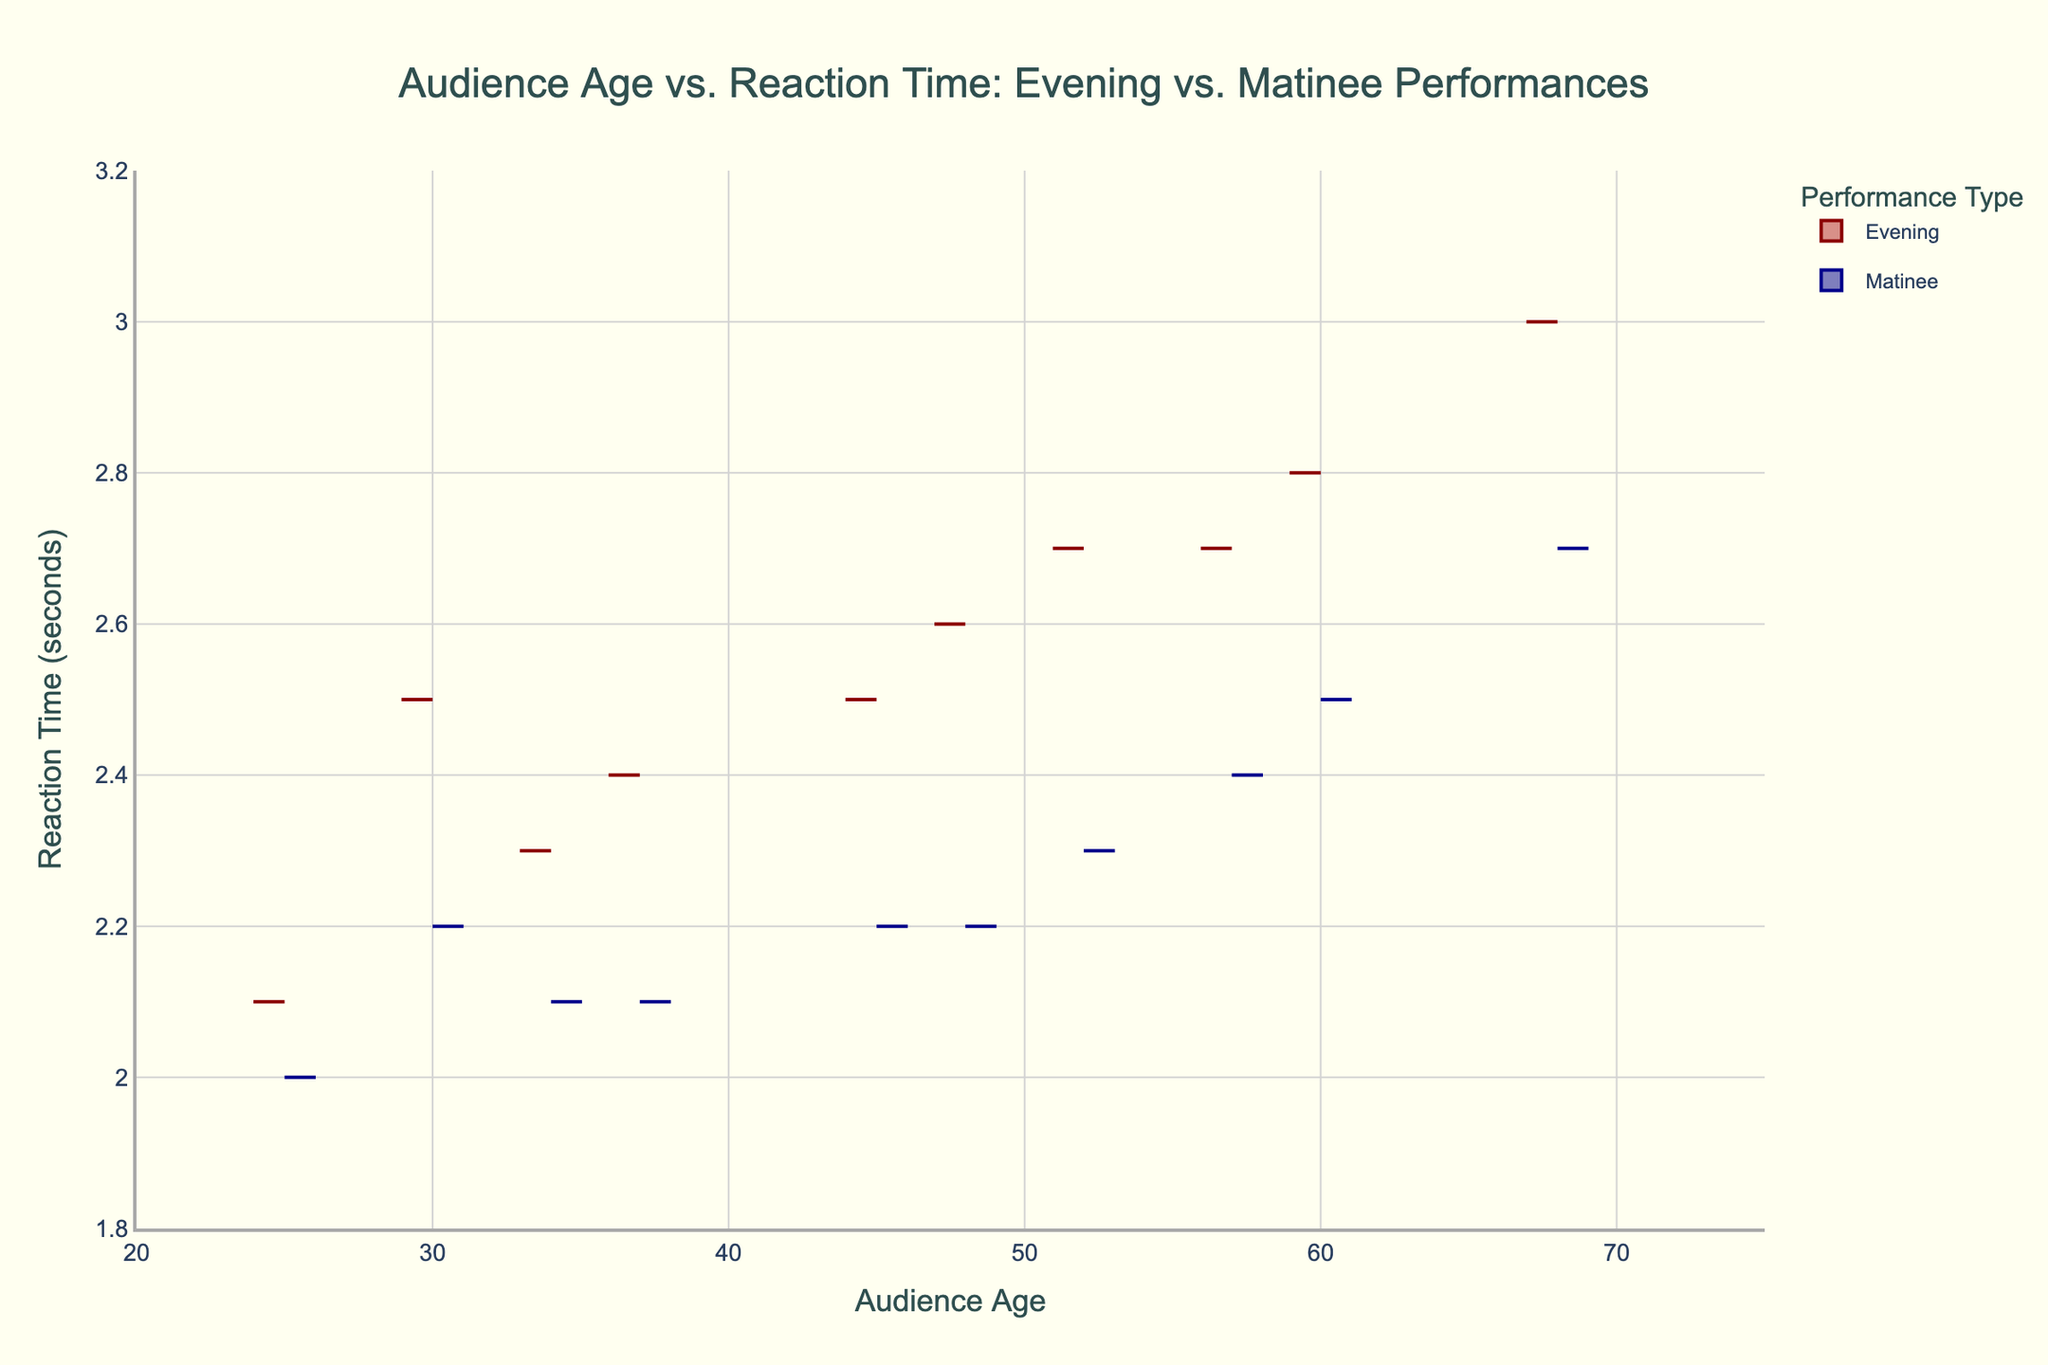What is the title of the mixed violin plot? The title of the plot is located at the top and is usually the most prominent text. In this figure, it reads "Audience Age vs. Reaction Time: Evening vs. Matinee Performances".
Answer: Audience Age vs. Reaction Time: Evening vs. Matinee Performances What colors represent 'Evening' and 'Matinee' performances in the plot? In the plot, the 'Evening' performances are represented by a dark red color on the negative side, while the 'Matinee' performances are shown in a dark blue color on the positive side.
Answer: Dark red and dark blue What audience age range does the plot cover? Look at the x-axis where the audience age is labeled to see the range. The x-axis extends from slightly below 20 to 75 years of age.
Answer: 20-75 years Which performance type has a wider spread of reaction times? Observe the spread of the violin plots along the y-axis for both 'Evening' and 'Matinee'. The 'Evening' plot appears to have a reaction time spread from about 2.1 to 3.0 seconds, whereas 'Matinee' has a slightly smaller range from about 2.0 to 2.7 seconds.
Answer: Evening At age 60, which performance type shows a longer reaction time? Check the vertical line (y-axis) for age 60 for both 'Evening' and 'Matinee'. 'Evening' shows a reaction time of 2.8 seconds, and 'Matinee' shows 2.5 seconds.
Answer: Evening Are there more audience members aged 45 attending Evening or Matinee performances? Examine the density (width) of the violin plots at age 45. The wider the plot at a specific age, the more audience members there are of that age. The plot appears slightly wider for 'Matinee' than for 'Evening' at age 45.
Answer: Matinee What is the median reaction time for Evening performances? The median is the middle value where the density of the plot is largest. For the 'Evening' side, it looks around 2.6 seconds.
Answer: 2.6 seconds How does the reaction time trend differ between Evening and Matinee performances as audience age increases? For both performance types, look at how reaction times change with audience age. 'Evening' reaction times generally increase from 2.1 at age 25 to 3.0 at age 68. 'Matinee' reaction times increase from 2.0 at age 25 to 2.7 at age 68.
Answer: Both increase, but Evening increases more What is the average reaction time for audience members aged 37 in Matinee performances? To find the average, note the reaction times for all occurrences at age 37 for Matinee (the y-values) which is around 2.1 seconds. Since there's only one value for this age, the average is the value itself.
Answer: 2.1 seconds Compare the reaction times of 34-year-old audience members between Evening and Matinee performances. Refer to the y-value corresponding to age 34 for both 'Evening' and 'Matinee'. In 'Evening', it's 2.3 seconds; in 'Matinee', it's 2.1 seconds.
Answer: Matinee is faster 